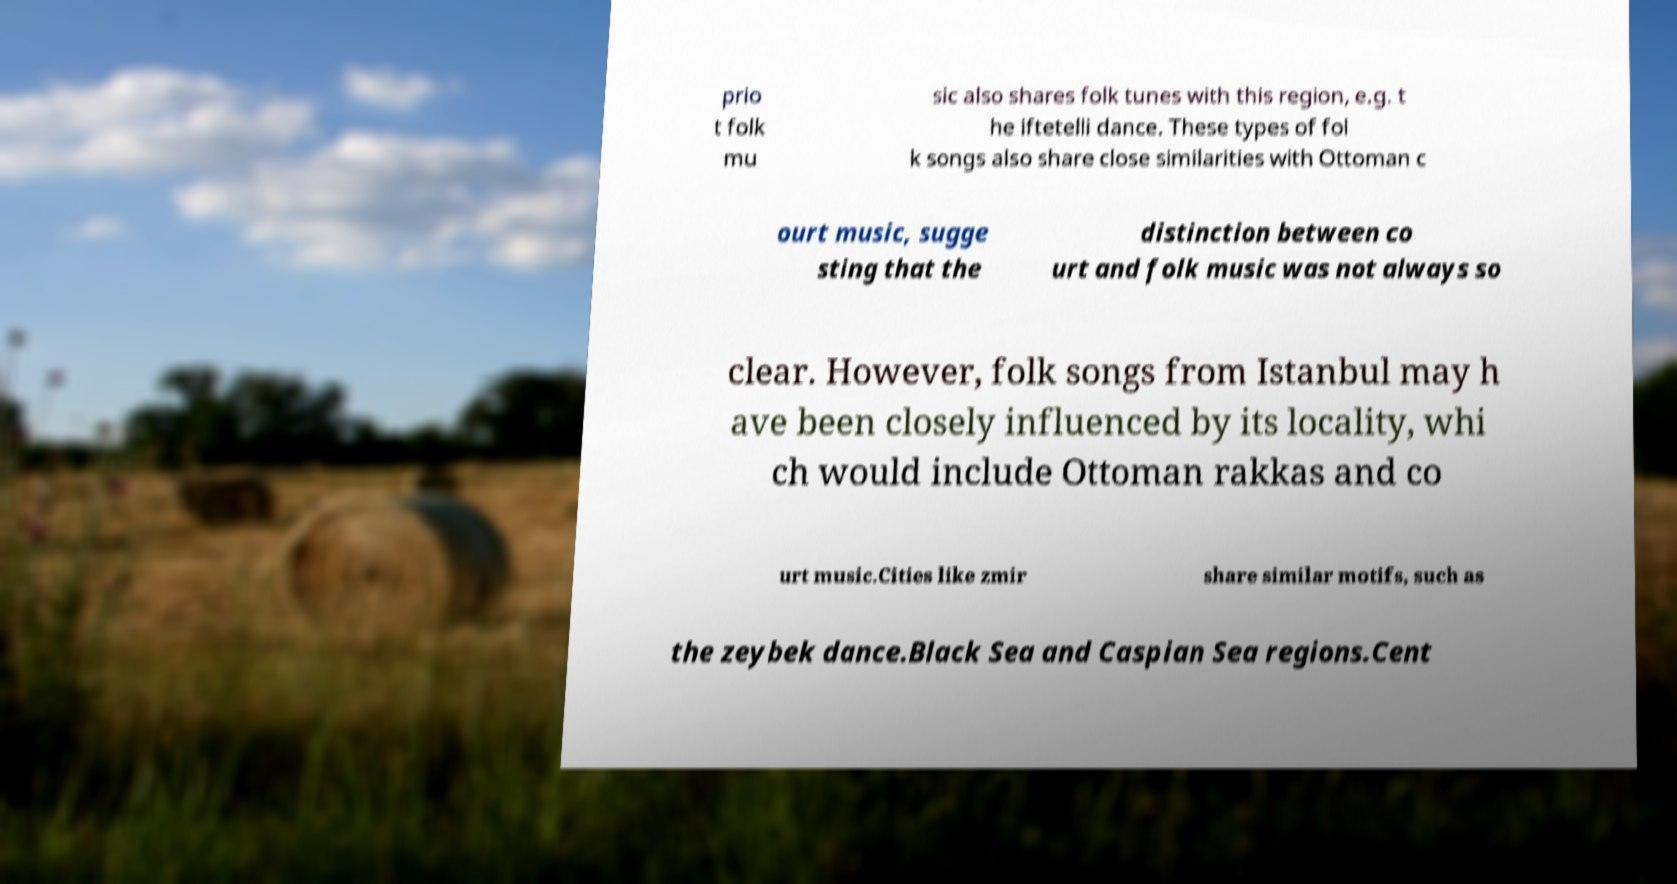I need the written content from this picture converted into text. Can you do that? prio t folk mu sic also shares folk tunes with this region, e.g. t he iftetelli dance. These types of fol k songs also share close similarities with Ottoman c ourt music, sugge sting that the distinction between co urt and folk music was not always so clear. However, folk songs from Istanbul may h ave been closely influenced by its locality, whi ch would include Ottoman rakkas and co urt music.Cities like zmir share similar motifs, such as the zeybek dance.Black Sea and Caspian Sea regions.Cent 